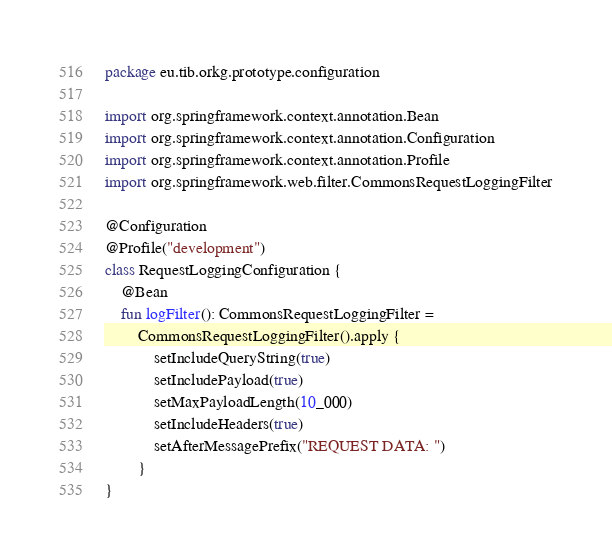<code> <loc_0><loc_0><loc_500><loc_500><_Kotlin_>package eu.tib.orkg.prototype.configuration

import org.springframework.context.annotation.Bean
import org.springframework.context.annotation.Configuration
import org.springframework.context.annotation.Profile
import org.springframework.web.filter.CommonsRequestLoggingFilter

@Configuration
@Profile("development")
class RequestLoggingConfiguration {
    @Bean
    fun logFilter(): CommonsRequestLoggingFilter =
        CommonsRequestLoggingFilter().apply {
            setIncludeQueryString(true)
            setIncludePayload(true)
            setMaxPayloadLength(10_000)
            setIncludeHeaders(true)
            setAfterMessagePrefix("REQUEST DATA: ")
        }
}
</code> 